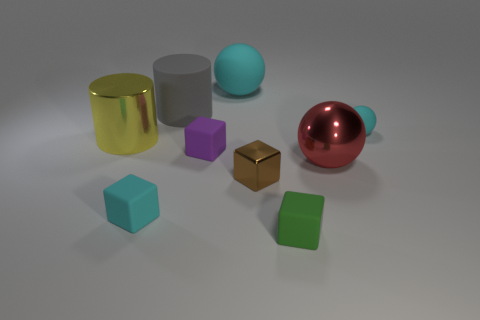Subtract 1 cubes. How many cubes are left? 3 Add 1 brown metallic things. How many objects exist? 10 Subtract all balls. How many objects are left? 6 Subtract all small cyan matte things. Subtract all tiny purple rubber cubes. How many objects are left? 6 Add 2 big shiny objects. How many big shiny objects are left? 4 Add 3 small cyan metallic balls. How many small cyan metallic balls exist? 3 Subtract 1 cyan cubes. How many objects are left? 8 